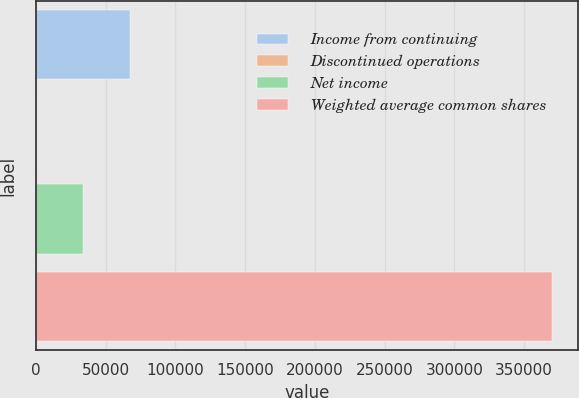<chart> <loc_0><loc_0><loc_500><loc_500><bar_chart><fcel>Income from continuing<fcel>Discontinued operations<fcel>Net income<fcel>Weighted average common shares<nl><fcel>67677<fcel>33<fcel>33855<fcel>370307<nl></chart> 